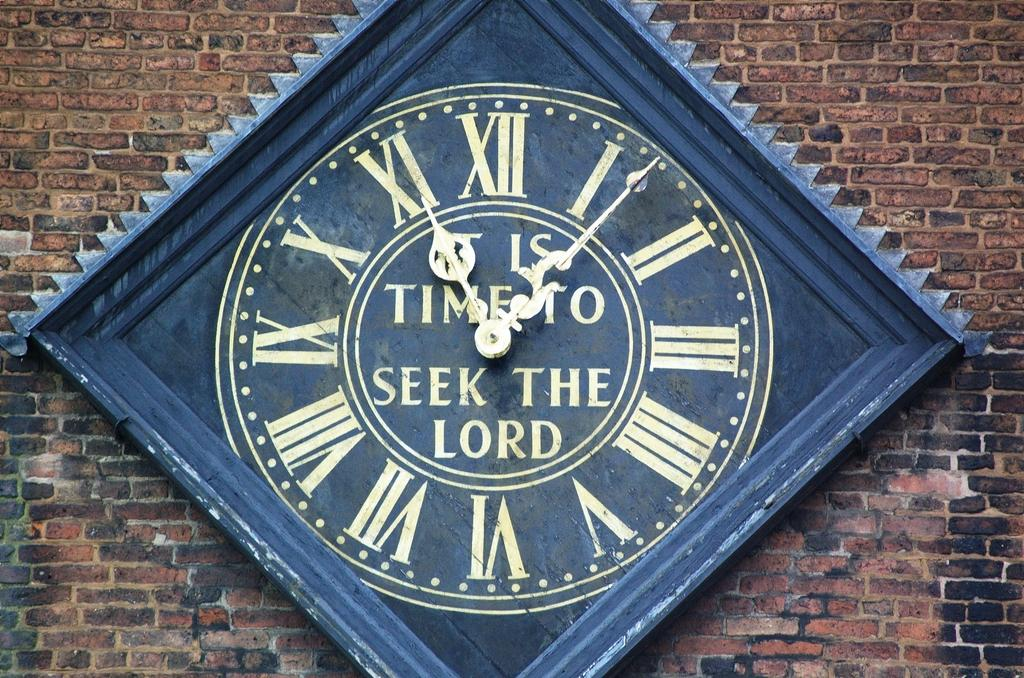<image>
Describe the image concisely. A blue clock is on display that says "It's time to seek the lord" 